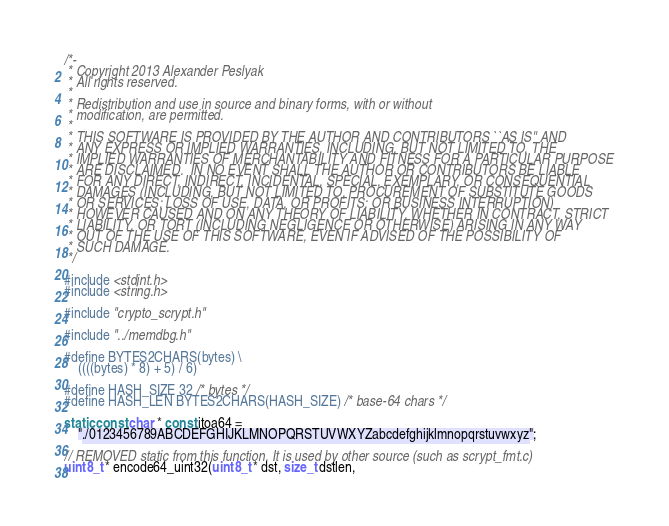<code> <loc_0><loc_0><loc_500><loc_500><_C_>/*-
 * Copyright 2013 Alexander Peslyak
 * All rights reserved.
 *
 * Redistribution and use in source and binary forms, with or without
 * modification, are permitted.
 *
 * THIS SOFTWARE IS PROVIDED BY THE AUTHOR AND CONTRIBUTORS ``AS IS'' AND
 * ANY EXPRESS OR IMPLIED WARRANTIES, INCLUDING, BUT NOT LIMITED TO, THE
 * IMPLIED WARRANTIES OF MERCHANTABILITY AND FITNESS FOR A PARTICULAR PURPOSE
 * ARE DISCLAIMED.  IN NO EVENT SHALL THE AUTHOR OR CONTRIBUTORS BE LIABLE
 * FOR ANY DIRECT, INDIRECT, INCIDENTAL, SPECIAL, EXEMPLARY, OR CONSEQUENTIAL
 * DAMAGES (INCLUDING, BUT NOT LIMITED TO, PROCUREMENT OF SUBSTITUTE GOODS
 * OR SERVICES; LOSS OF USE, DATA, OR PROFITS; OR BUSINESS INTERRUPTION)
 * HOWEVER CAUSED AND ON ANY THEORY OF LIABILITY, WHETHER IN CONTRACT, STRICT
 * LIABILITY, OR TORT (INCLUDING NEGLIGENCE OR OTHERWISE) ARISING IN ANY WAY
 * OUT OF THE USE OF THIS SOFTWARE, EVEN IF ADVISED OF THE POSSIBILITY OF
 * SUCH DAMAGE.
 */

#include <stdint.h>
#include <string.h>

#include "crypto_scrypt.h"

#include "../memdbg.h"

#define BYTES2CHARS(bytes) \
	((((bytes) * 8) + 5) / 6)

#define HASH_SIZE 32 /* bytes */
#define HASH_LEN BYTES2CHARS(HASH_SIZE) /* base-64 chars */

static const char * const itoa64 =
	"./0123456789ABCDEFGHIJKLMNOPQRSTUVWXYZabcdefghijklmnopqrstuvwxyz";

// REMOVED static from this function. It is used by other source (such as scrypt_fmt.c)
uint8_t * encode64_uint32(uint8_t * dst, size_t dstlen,</code> 